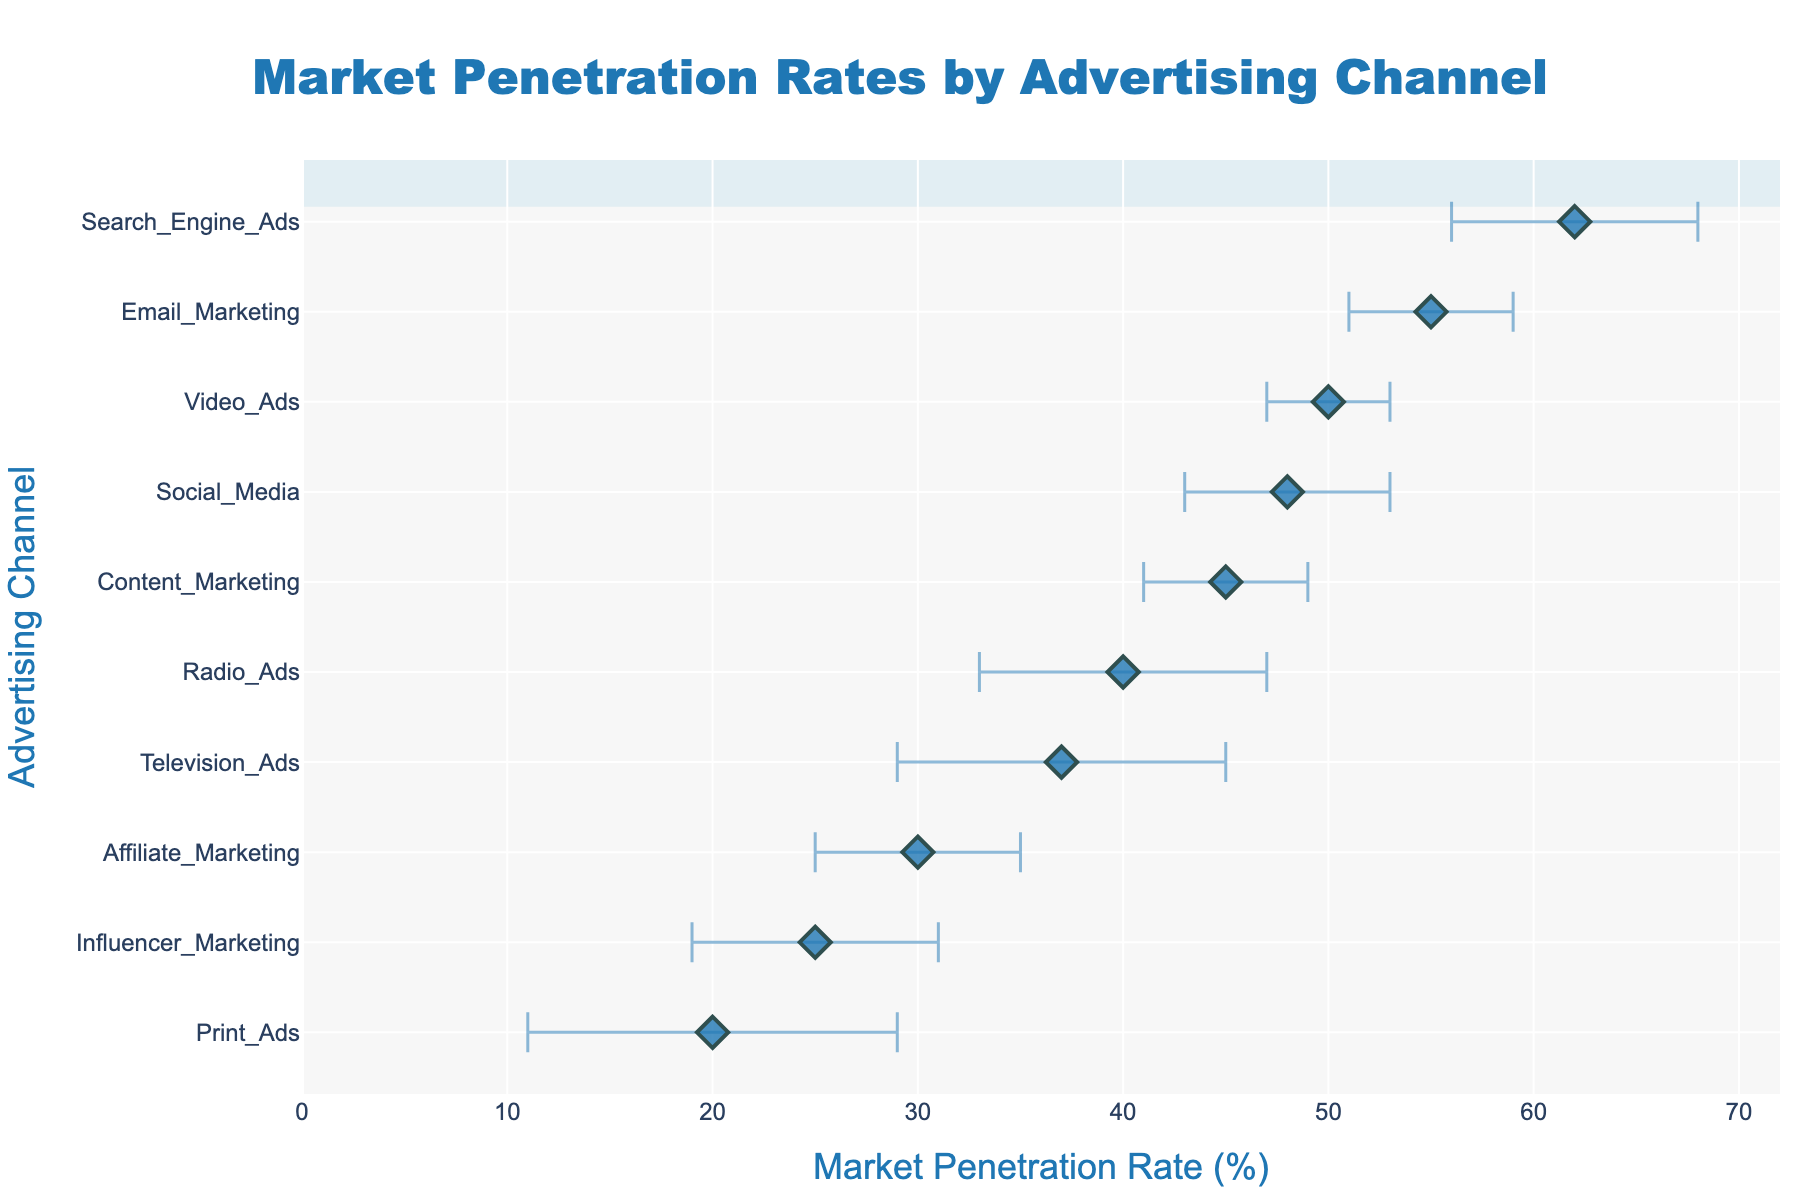Which advertising channel has the highest market penetration rate? The highest point on the x-axis corresponds to Search Engine Ads, having the highest market penetration rate.
Answer: Search Engine Ads What is the market penetration rate for Email Marketing? Locate Email Marketing on the y-axis and read its corresponding x-axis value. The market penetration rate is 55%.
Answer: 55% Which advertising channel has the largest uncertainty range? Look for the widest error bars. Print Ads has the largest uncertainty range of 9.
Answer: Print Ads What is the difference in market penetration rates between Social Media and Television Ads? Subtract the market penetration rate of Television Ads (37%) from that of Social Media (48%). 48% - 37% = 11%.
Answer: 11% How many advertising channels have a market penetration rate above 40? Count the points that have x-axis values greater than 40. There are 6 channels above 40: Social Media, Email Marketing, Search Engine Ads, Radio Ads, Content Marketing, and Video Ads.
Answer: 6 Which advertising channel has the lowest market penetration rate and what is its value? The lowest point on the x-axis corresponds to Print Ads, having a market penetration rate of 20%.
Answer: Print Ads, 20% What is the uncertainty range for Influencer Marketing? Locate Influencer Marketing on the y-axis and identify its error bar. The uncertainty range is 6.
Answer: 6 Compare the market penetration rates of Video Ads and Social Media. Which is higher? Video Ads has a market penetration rate of 50%, while Social Media has a rate of 48%. Video Ads is higher.
Answer: Video Ads What is the average market penetration rate for Email Marketing and Content Marketing? Add their rates and divide by 2. (55% + 45%) / 2 = 50%.
Answer: 50% What is the difference in the uncertainty range between Radio Ads and Affiliate Marketing? Subtract the uncertainty range of Affiliate Marketing (5) from Radio Ads (7). 7 - 5 = 2.
Answer: 2 